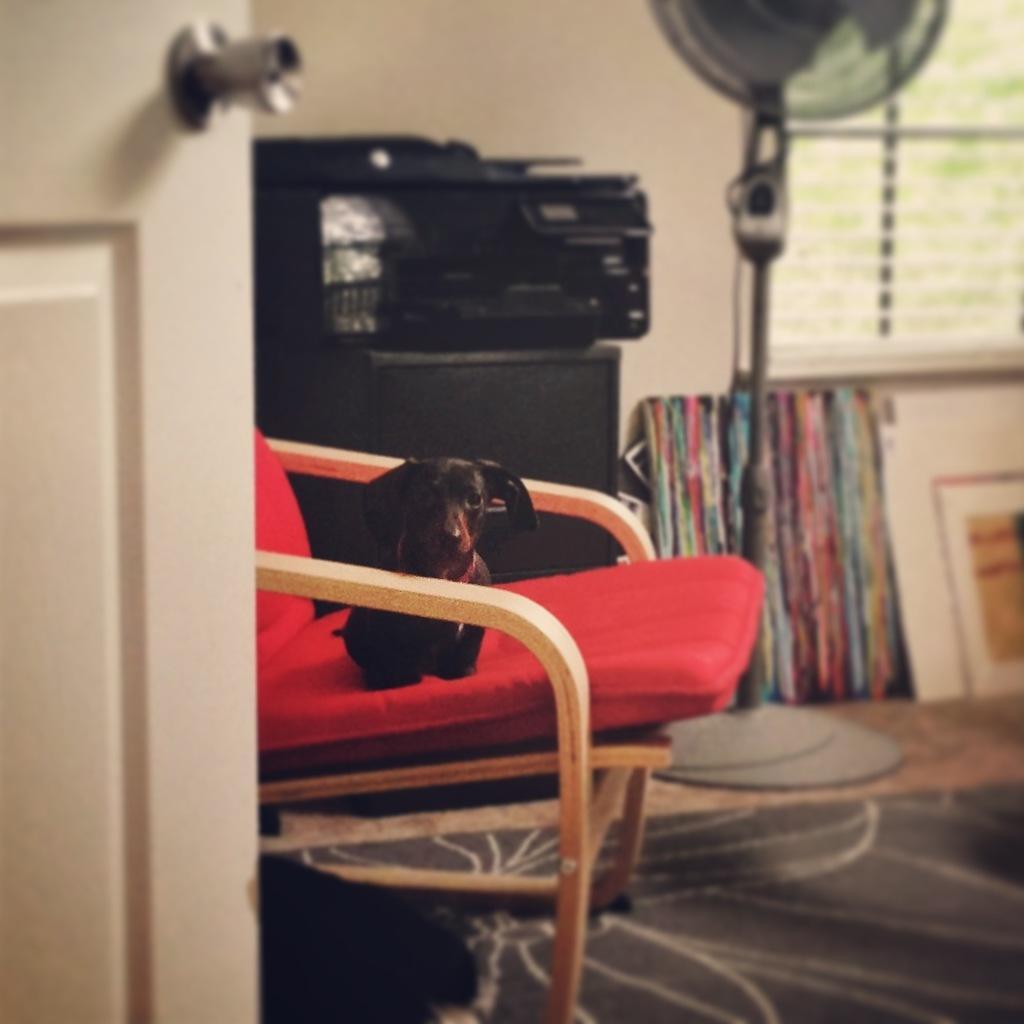Describe this image in one or two sentences. This is a picture of a room in this picture in the center there is one chair, on the chair there is one dog and in the background there are some objects, speaker, pole, mirror, window, photo frame, wall. At the bottom there is floor and on the left side there is door. 